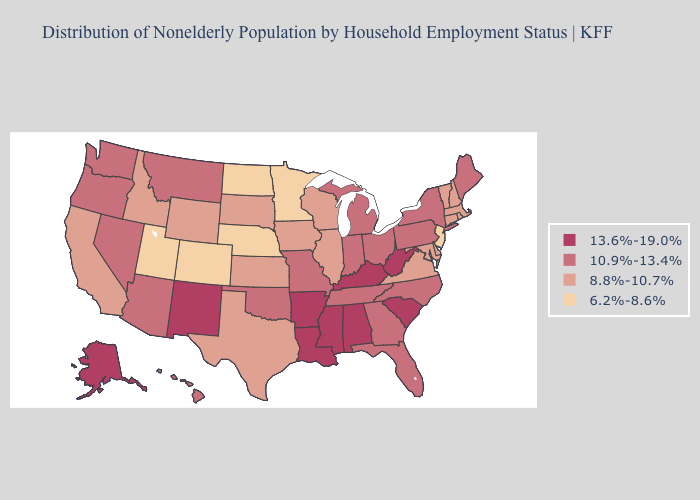Does the map have missing data?
Write a very short answer. No. What is the lowest value in states that border Oklahoma?
Keep it brief. 6.2%-8.6%. Name the states that have a value in the range 10.9%-13.4%?
Be succinct. Arizona, Florida, Georgia, Hawaii, Indiana, Maine, Michigan, Missouri, Montana, Nevada, New York, North Carolina, Ohio, Oklahoma, Oregon, Pennsylvania, Tennessee, Washington. Does Utah have the lowest value in the USA?
Write a very short answer. Yes. Name the states that have a value in the range 6.2%-8.6%?
Concise answer only. Colorado, Minnesota, Nebraska, New Jersey, North Dakota, Utah. Among the states that border Missouri , which have the lowest value?
Short answer required. Nebraska. Does Delaware have the lowest value in the South?
Answer briefly. Yes. What is the value of New York?
Answer briefly. 10.9%-13.4%. What is the lowest value in states that border Maine?
Be succinct. 8.8%-10.7%. What is the highest value in the MidWest ?
Concise answer only. 10.9%-13.4%. What is the value of Illinois?
Concise answer only. 8.8%-10.7%. What is the value of Connecticut?
Short answer required. 8.8%-10.7%. What is the value of Minnesota?
Short answer required. 6.2%-8.6%. Which states have the lowest value in the USA?
Quick response, please. Colorado, Minnesota, Nebraska, New Jersey, North Dakota, Utah. Which states have the lowest value in the USA?
Quick response, please. Colorado, Minnesota, Nebraska, New Jersey, North Dakota, Utah. 